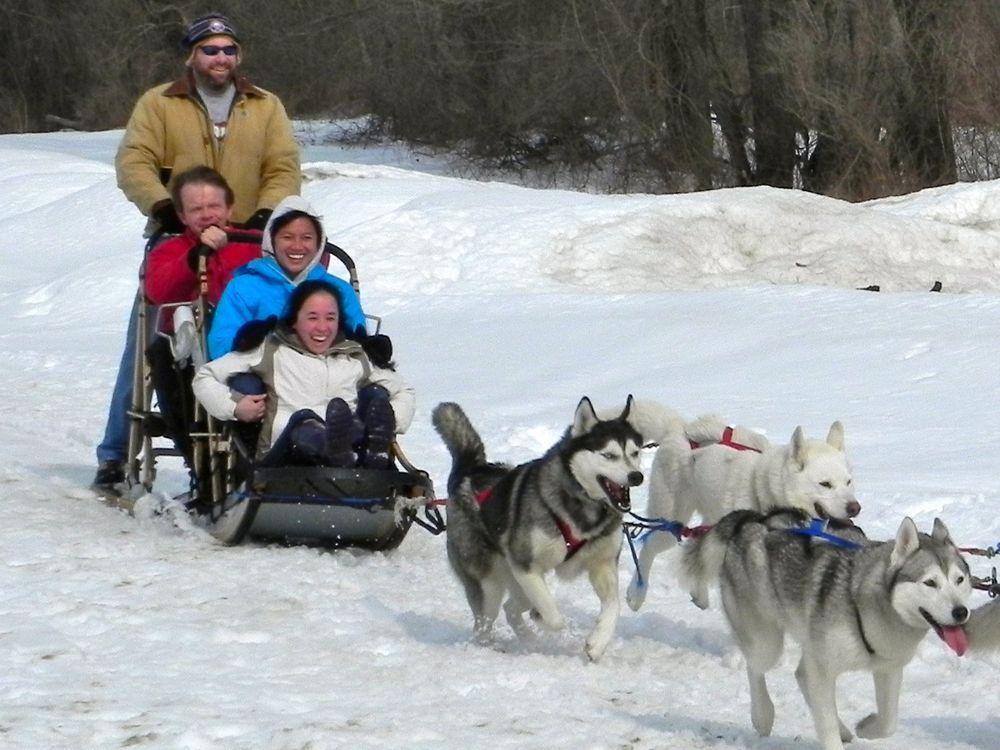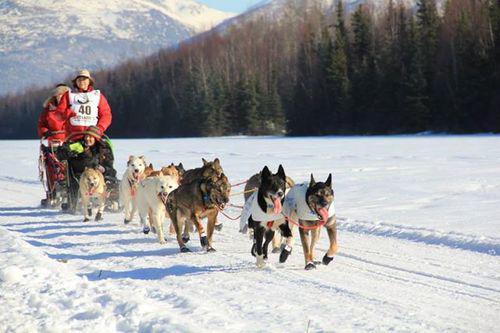The first image is the image on the left, the second image is the image on the right. Evaluate the accuracy of this statement regarding the images: "The dog sled teams in the left and right images move rightward at an angle over the snow and contain traditional husky-type sled dogs.". Is it true? Answer yes or no. Yes. The first image is the image on the left, the second image is the image on the right. Examine the images to the left and right. Is the description "The dogs in both pictures are pulling the sled towards the right." accurate? Answer yes or no. Yes. 